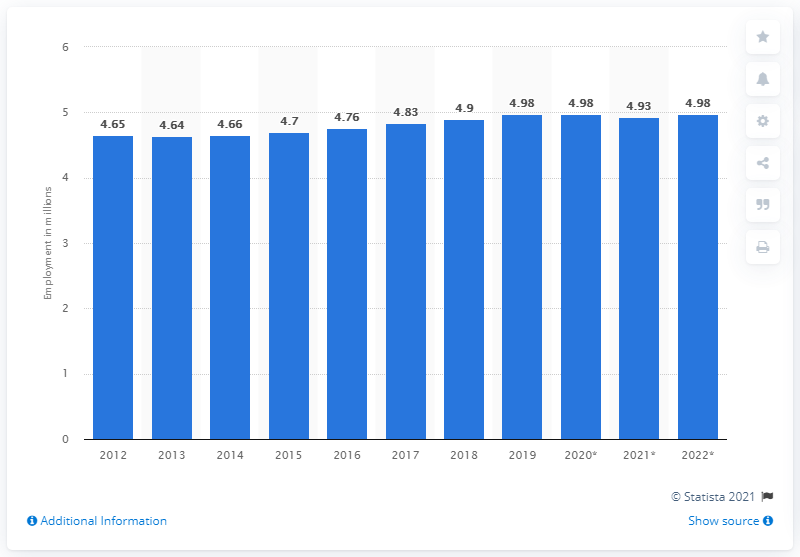Indicate a few pertinent items in this graphic. In 2019, there were approximately 4.98 million people employed in Belgium. 